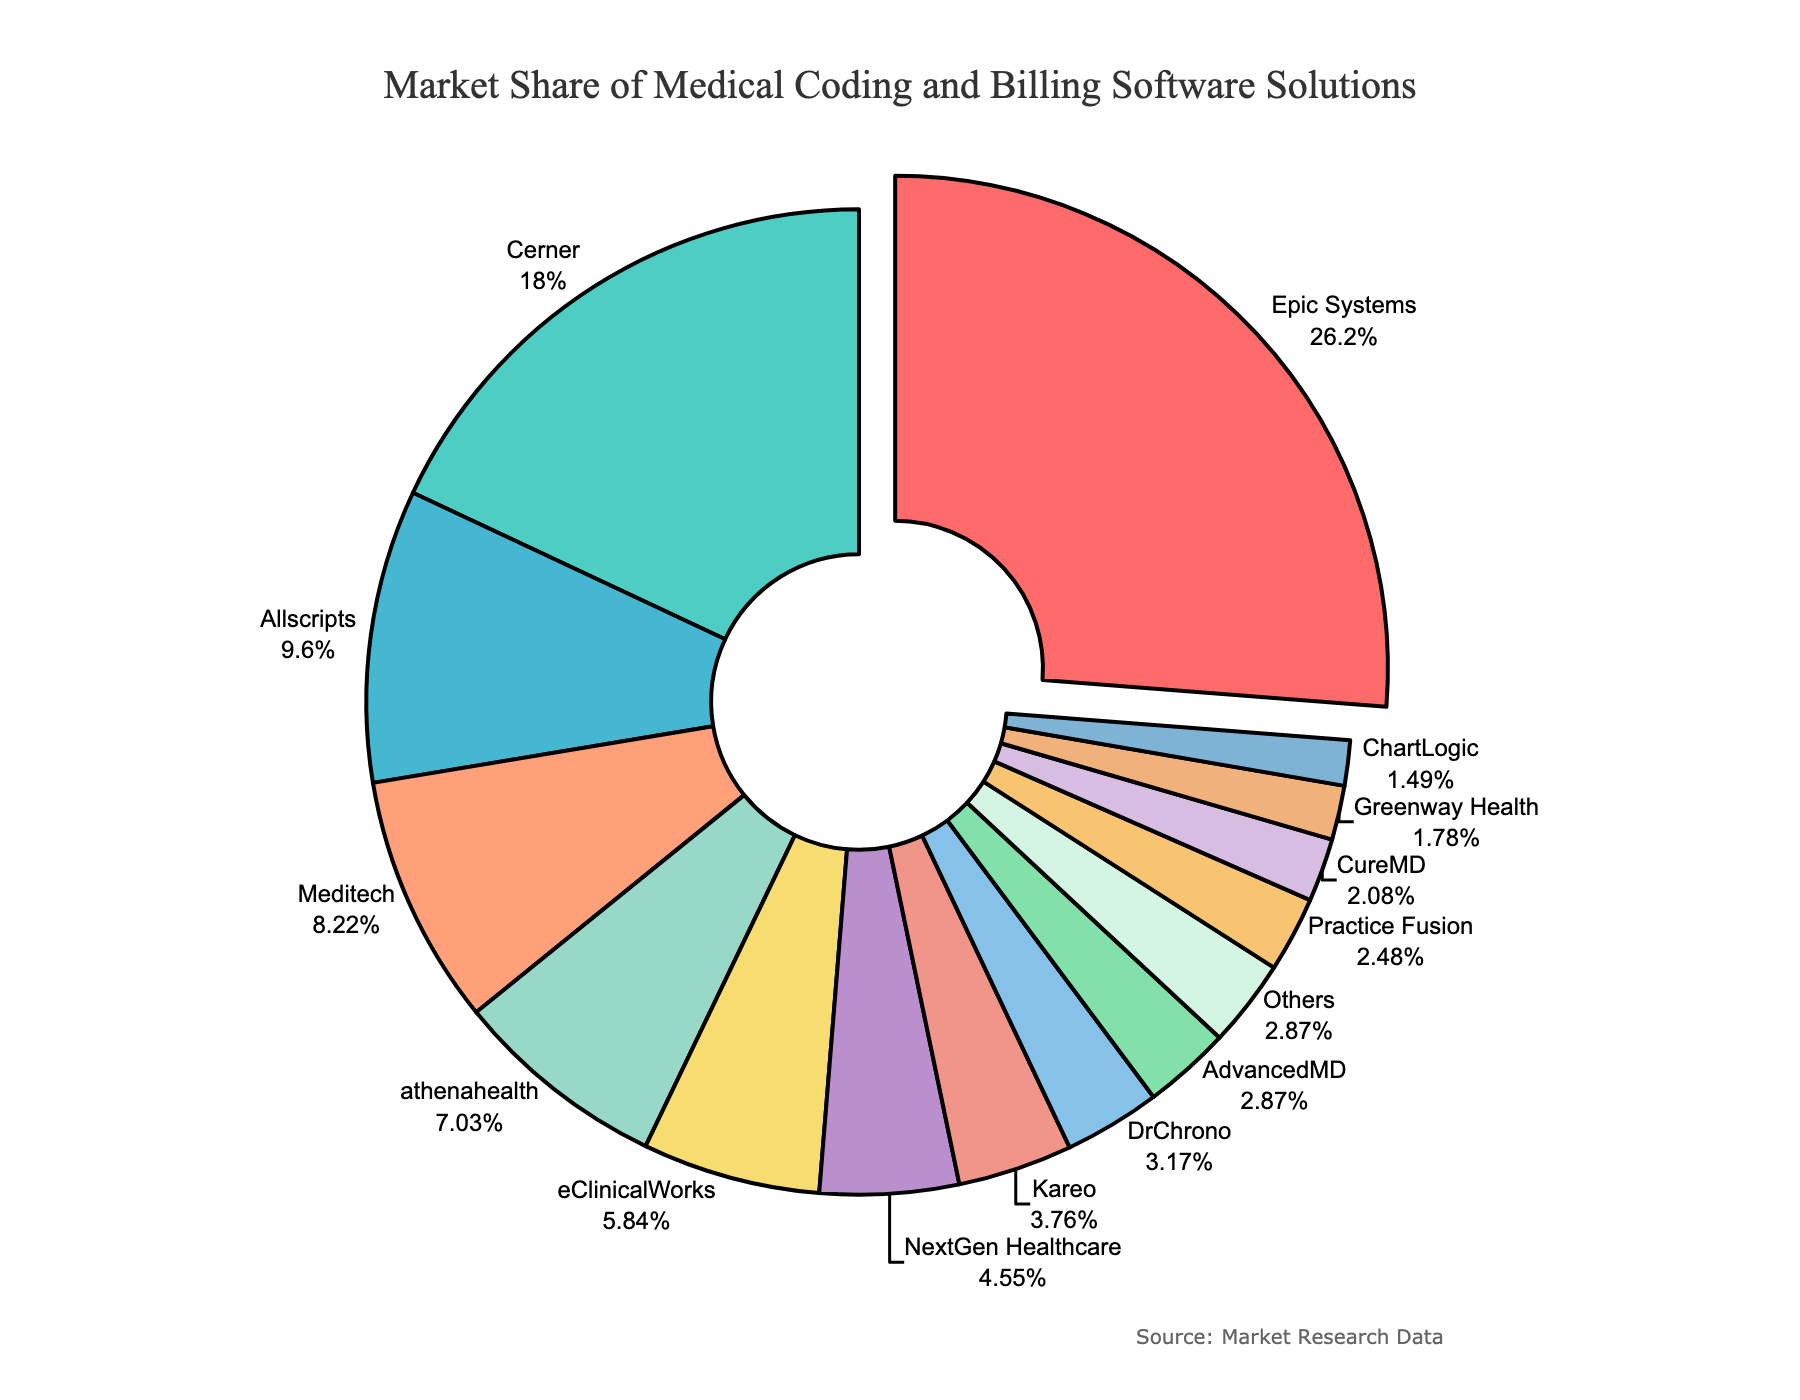Which software has the largest market share? The pie chart shows each software's market share by slice size. The largest slice is labeled "Epic Systems" at 26.5%, making it the most significant market shareholder.
Answer: Epic Systems Which software solutions have a combined market share of over 40%? Adding the market shares of the largest slices until they exceed 40%, we start with Epic Systems (26.5%) and Cerner (18.2%). Their combined market share is 26.5% + 18.2% = 44.7%.
Answer: Epic Systems and Cerner What is the difference in market share between the largest and the smallest software solutions? The largest market share is Epic Systems at 26.5%, and the smallest is Greenway Health at 1.8%. The difference is 26.5% - 1.8% = 24.7%.
Answer: 24.7% Which software has a market share closest to 10%? The pie chart shows percentages; the software closest to 10% is Allscripts at 9.7%.
Answer: Allscripts How many software solutions have a market share less than 5%? Counting the slices with market shares less than 5% in the chart: NextGen Healthcare, Kareo, DrChrono, AdvancedMD, Practice Fusion, CureMD, Greenway Health, and ChartLogic is 8 solutions.
Answer: 8 What is the combined market share of software solutions with market shares under 3%? Adding the market shares of AdvancedMD (2.9%), Practice Fusion (2.5%), CureMD (2.1%), Greenway Health (1.8%), and ChartLogic (1.5%), gives 2.9% + 2.5% + 2.1% + 1.8% + 1.5% = 10.8%.
Answer: 10.8% Which software has the smallest marked slice not grouped under 'Others'? The slice with the smallest market share, not grouped under 'Others', is Greenway Health at 1.8%.
Answer: Greenway Health What is the aggregate market share of the top three software solutions? Summing the market shares of Epic Systems (26.5%), Cerner (18.2%), and Allscripts (9.7%), we get 26.5% + 18.2% + 9.7% = 54.4%.
Answer: 54.4% Which two software solutions have a combined market share that is closest to 15%? Consider software pairs: eClinicalWorks (5.9%) and athenahealth (7.1%) have a combined share of 5.9% + 7.1% = 13%. NextGen Healthcare (4.6%) and Kareo (3.8%) have a combined share of 4.6% + 3.8% = 8.4%. AdvancedMD (2.9%) and Practice Fusion (2.5%) have a combined share of 2.9% + 2.5% = 5.4%. The closest combination to 15% is eClinicalWorks and athenahealth with 13%.
Answer: eClinicalWorks and athenahealth 